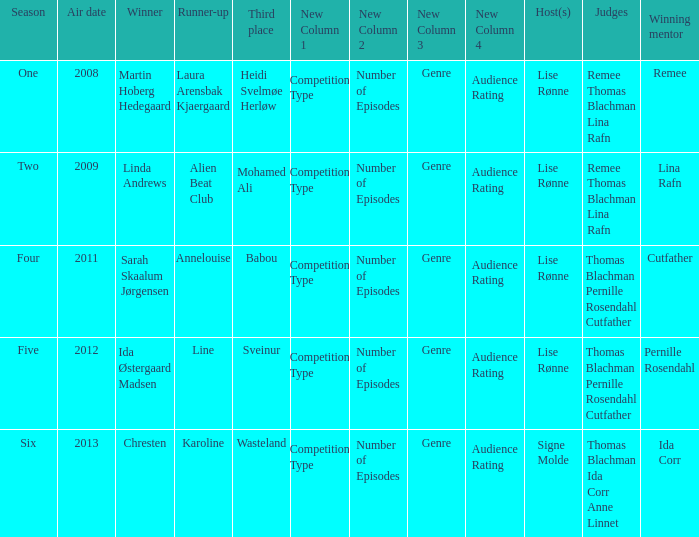Who won third place in season four? Babou. 